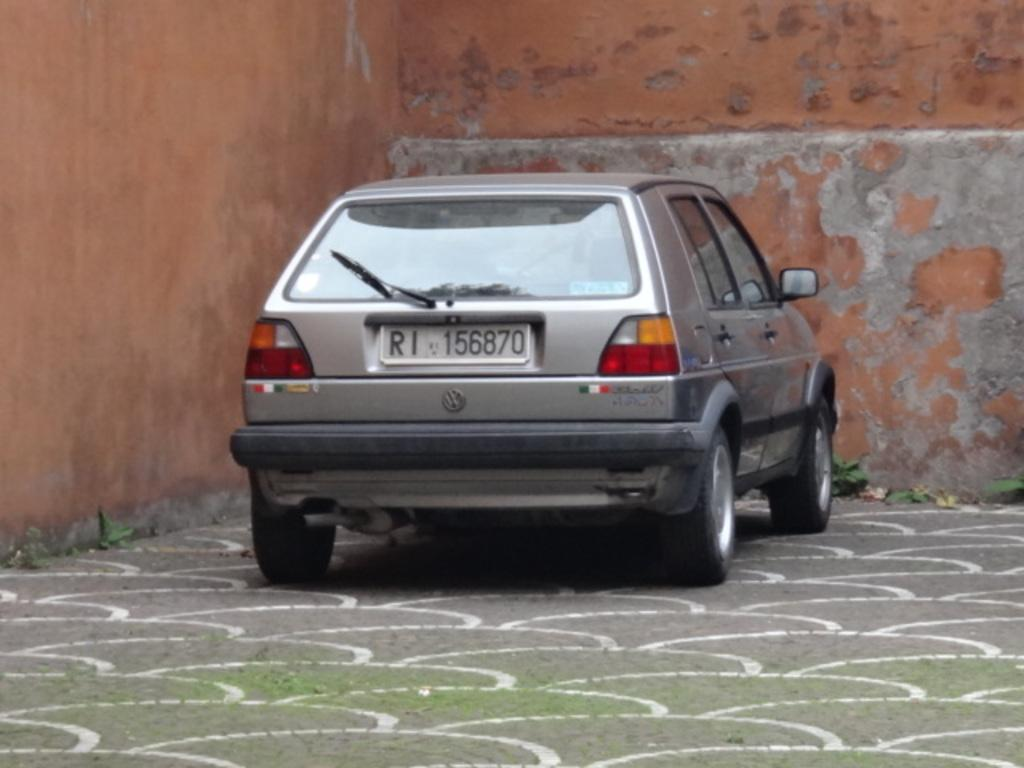What is the main subject of the image? The main subject of the image is a car. Where is the car located in the image? The car is on the road in the image. What can be seen in the background of the image? There is a wall in the background of the image. What type of clouds can be seen in the image? There are no clouds visible in the image; it features a car on the road with a wall in the background. 